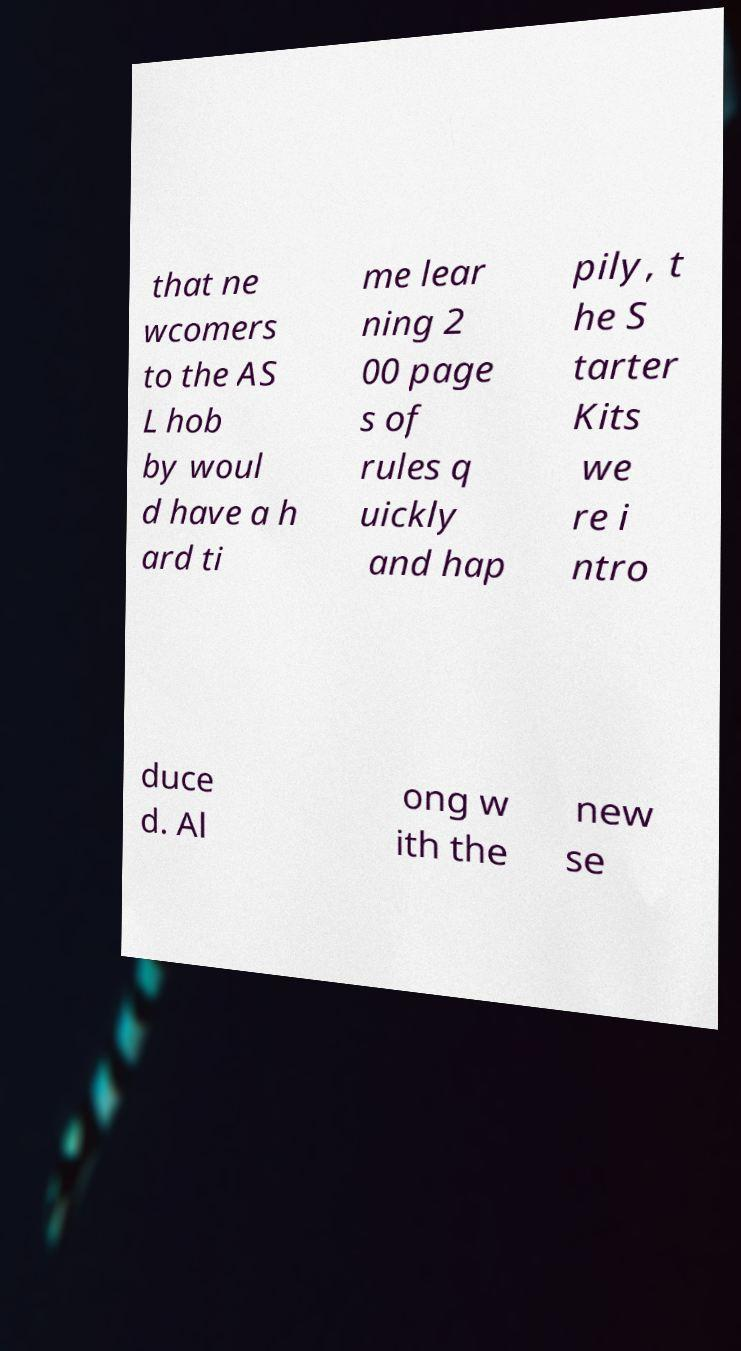Could you assist in decoding the text presented in this image and type it out clearly? that ne wcomers to the AS L hob by woul d have a h ard ti me lear ning 2 00 page s of rules q uickly and hap pily, t he S tarter Kits we re i ntro duce d. Al ong w ith the new se 